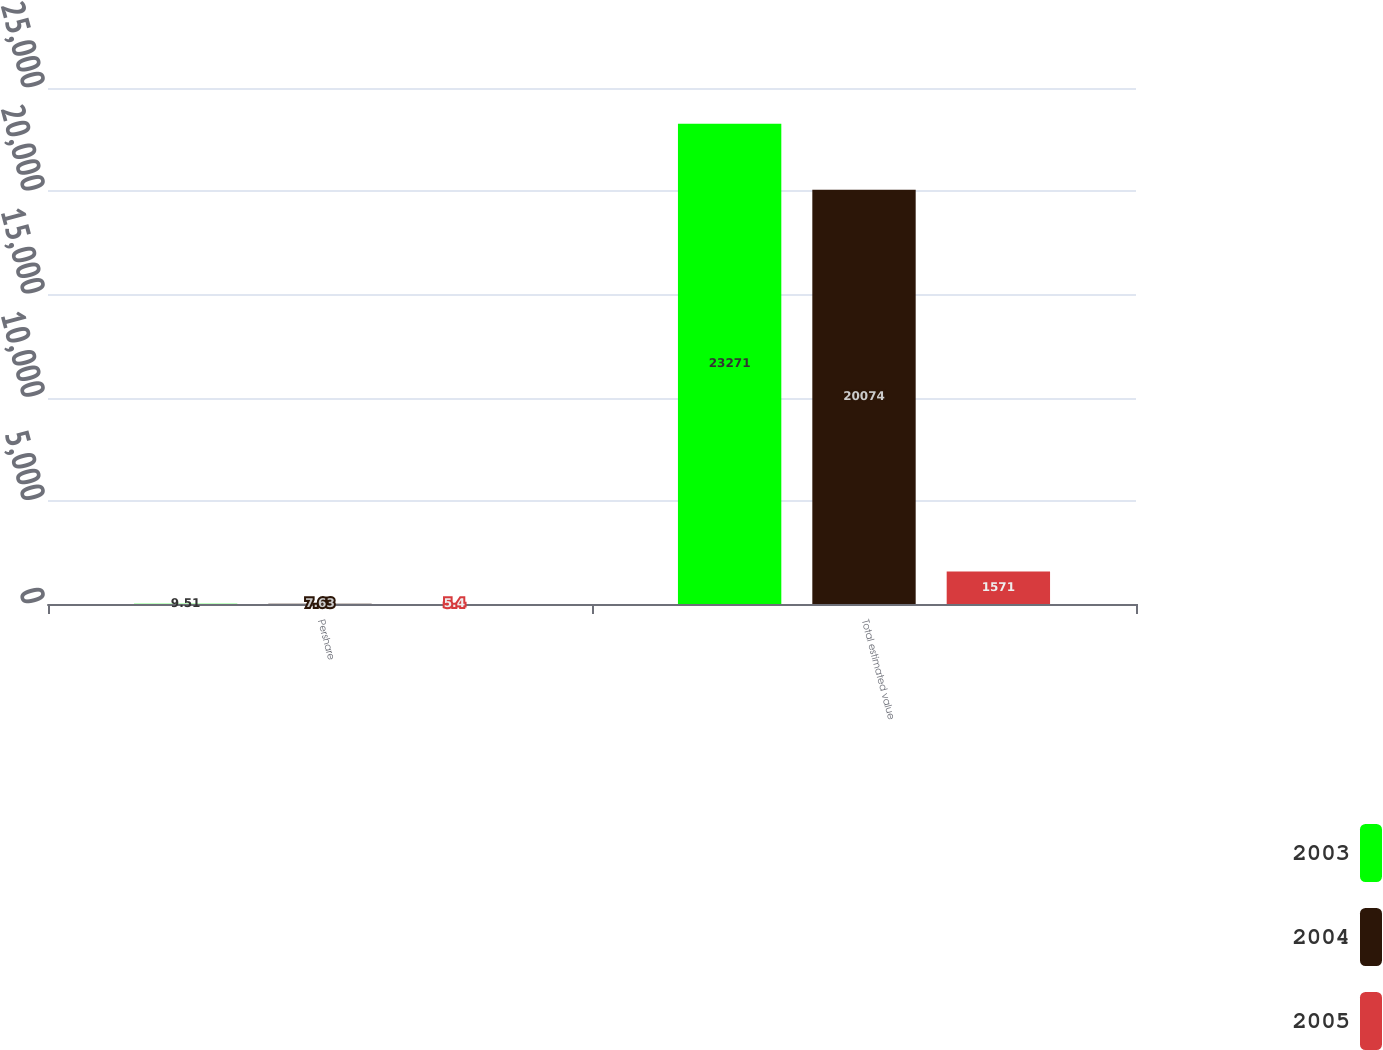Convert chart. <chart><loc_0><loc_0><loc_500><loc_500><stacked_bar_chart><ecel><fcel>Pershare<fcel>Total estimated value<nl><fcel>2003<fcel>9.51<fcel>23271<nl><fcel>2004<fcel>7.63<fcel>20074<nl><fcel>2005<fcel>5.4<fcel>1571<nl></chart> 